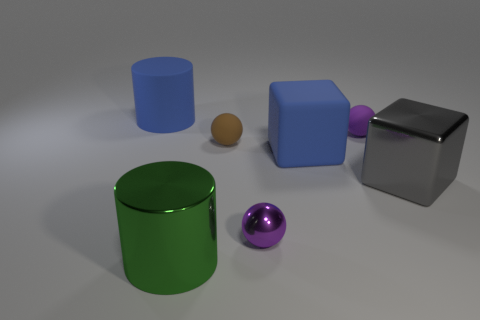Subtract all red cylinders. Subtract all green blocks. How many cylinders are left? 2 Add 3 large gray objects. How many objects exist? 10 Subtract all cylinders. How many objects are left? 5 Add 2 gray blocks. How many gray blocks are left? 3 Add 1 small shiny balls. How many small shiny balls exist? 2 Subtract 1 blue cylinders. How many objects are left? 6 Subtract all small purple metallic spheres. Subtract all big rubber things. How many objects are left? 4 